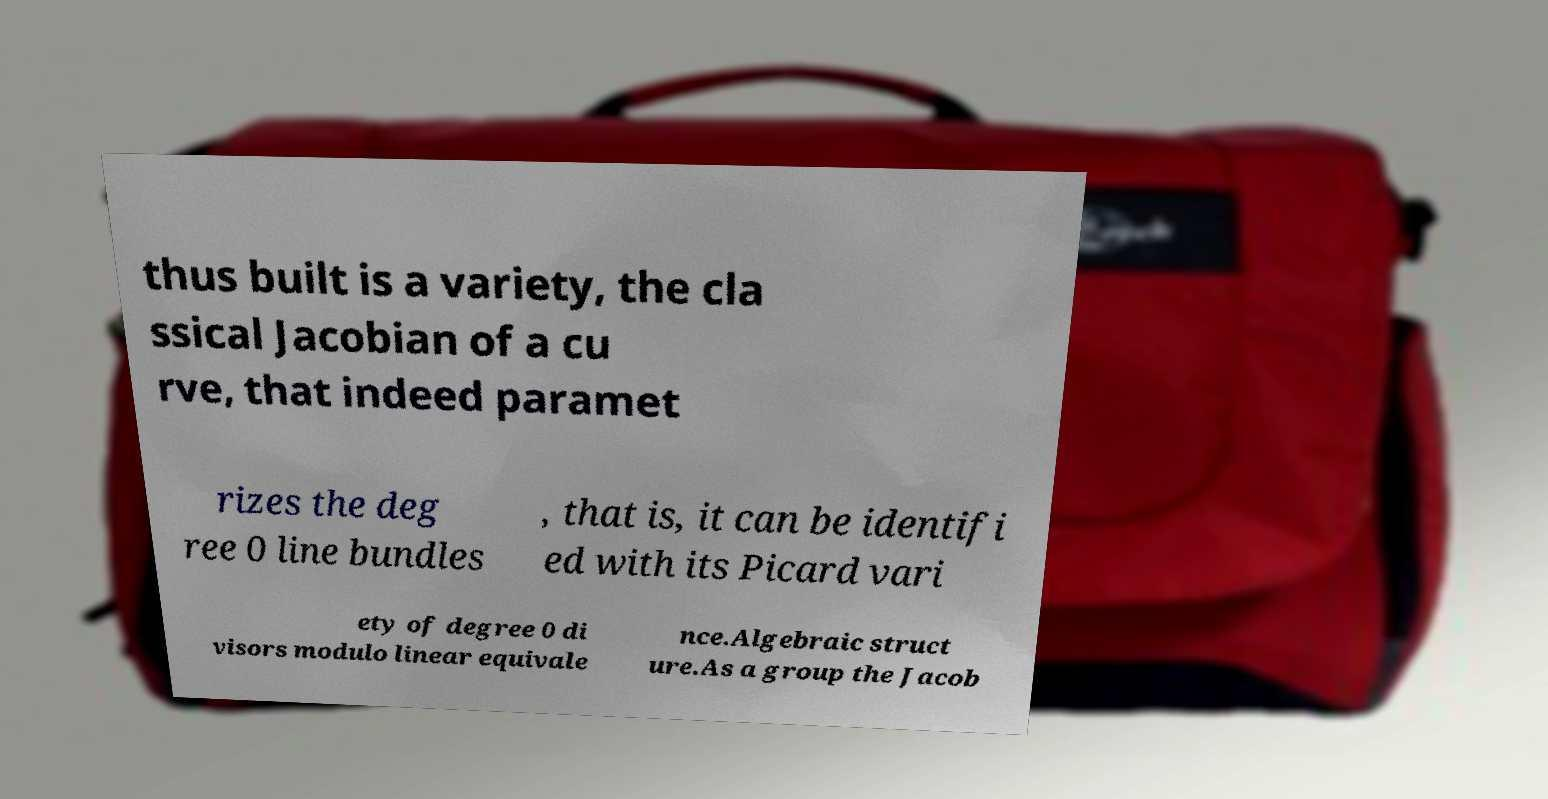Please identify and transcribe the text found in this image. thus built is a variety, the cla ssical Jacobian of a cu rve, that indeed paramet rizes the deg ree 0 line bundles , that is, it can be identifi ed with its Picard vari ety of degree 0 di visors modulo linear equivale nce.Algebraic struct ure.As a group the Jacob 